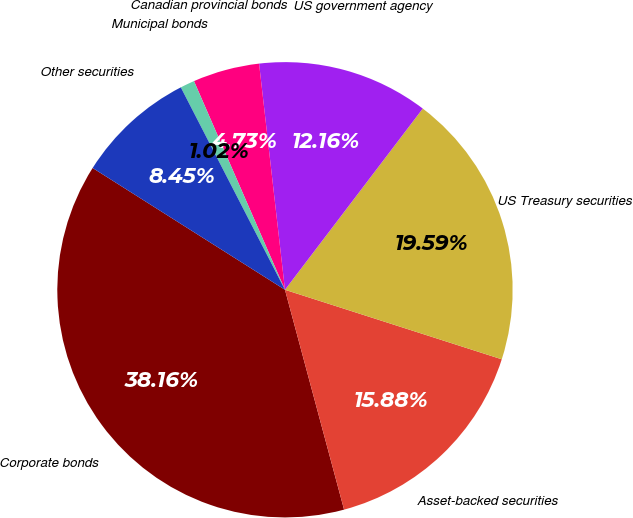Convert chart to OTSL. <chart><loc_0><loc_0><loc_500><loc_500><pie_chart><fcel>Corporate bonds<fcel>Asset-backed securities<fcel>US Treasury securities<fcel>US government agency<fcel>Canadian provincial bonds<fcel>Municipal bonds<fcel>Other securities<nl><fcel>38.16%<fcel>15.88%<fcel>19.59%<fcel>12.16%<fcel>4.73%<fcel>1.02%<fcel>8.45%<nl></chart> 